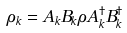<formula> <loc_0><loc_0><loc_500><loc_500>\rho _ { k } = A _ { k } B _ { k } \rho A _ { k } ^ { \dagger } B _ { k } ^ { \dagger }</formula> 